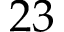<formula> <loc_0><loc_0><loc_500><loc_500>2 3</formula> 